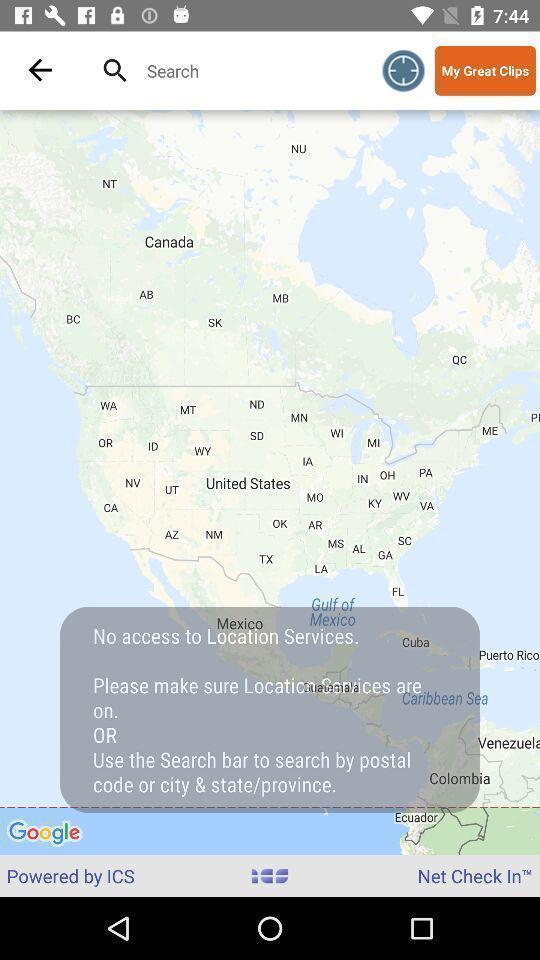What is the overall content of this screenshot? Screen showing no access to location services. 